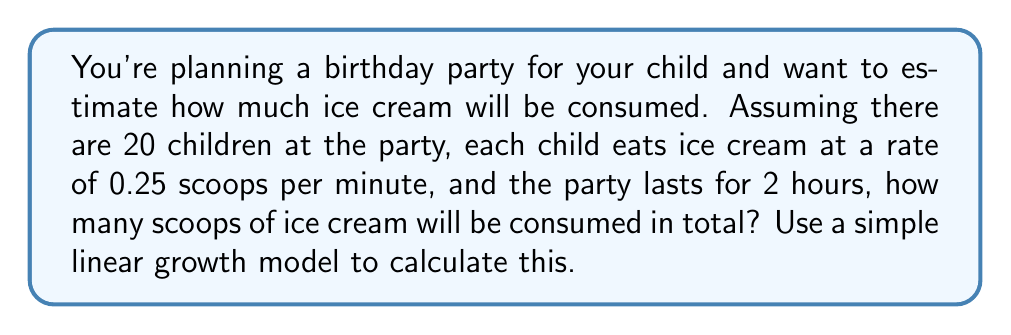Provide a solution to this math problem. To solve this problem, we can use a basic linear growth model from population dynamics. In this case, our "population" is the number of ice cream scoops consumed.

Let's define our variables:
$N(t)$ = Number of ice cream scoops consumed at time $t$
$r$ = Rate of ice cream consumption per child per minute
$P$ = Number of children at the party
$T$ = Total time of the party in minutes

Given:
$r = 0.25$ scoops per minute
$P = 20$ children
$T = 2$ hours = 120 minutes

The linear growth model is given by the equation:

$$N(t) = rPt$$

Where $rP$ represents the total rate of consumption for all children.

To find the total number of scoops consumed during the party, we calculate $N(T)$:

$$N(T) = rPT$$
$$N(120) = 0.25 \times 20 \times 120$$
$$N(120) = 600$$

Therefore, the total number of ice cream scoops consumed during the 2-hour party will be 600 scoops.
Answer: 600 scoops of ice cream 